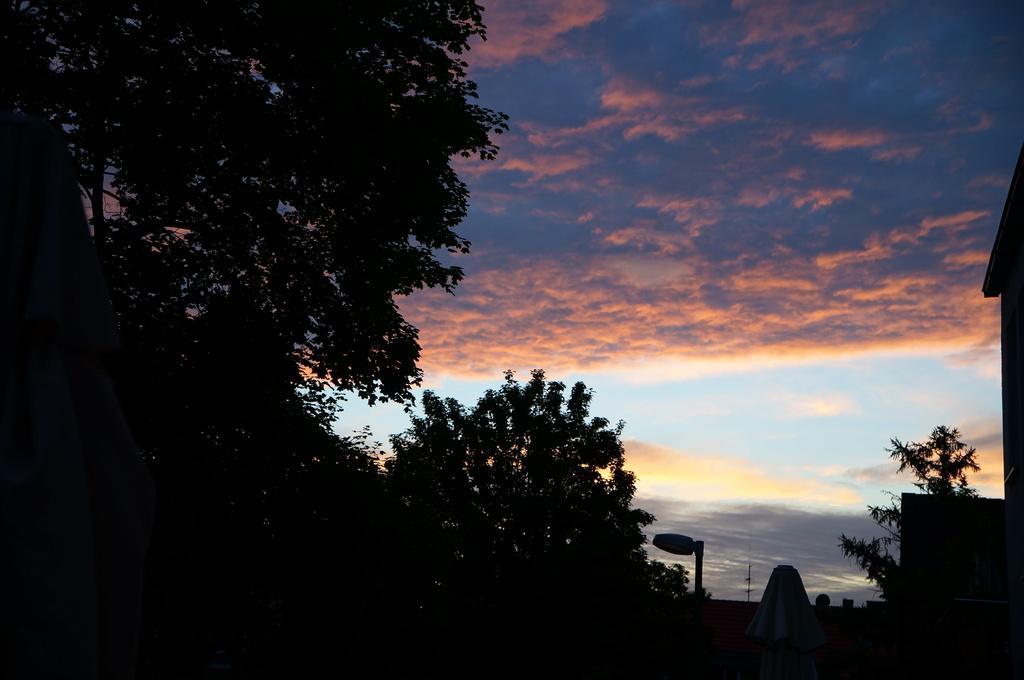Can you describe this image briefly? In the image there are many trees and in the background there is a sky, it is colorful. 